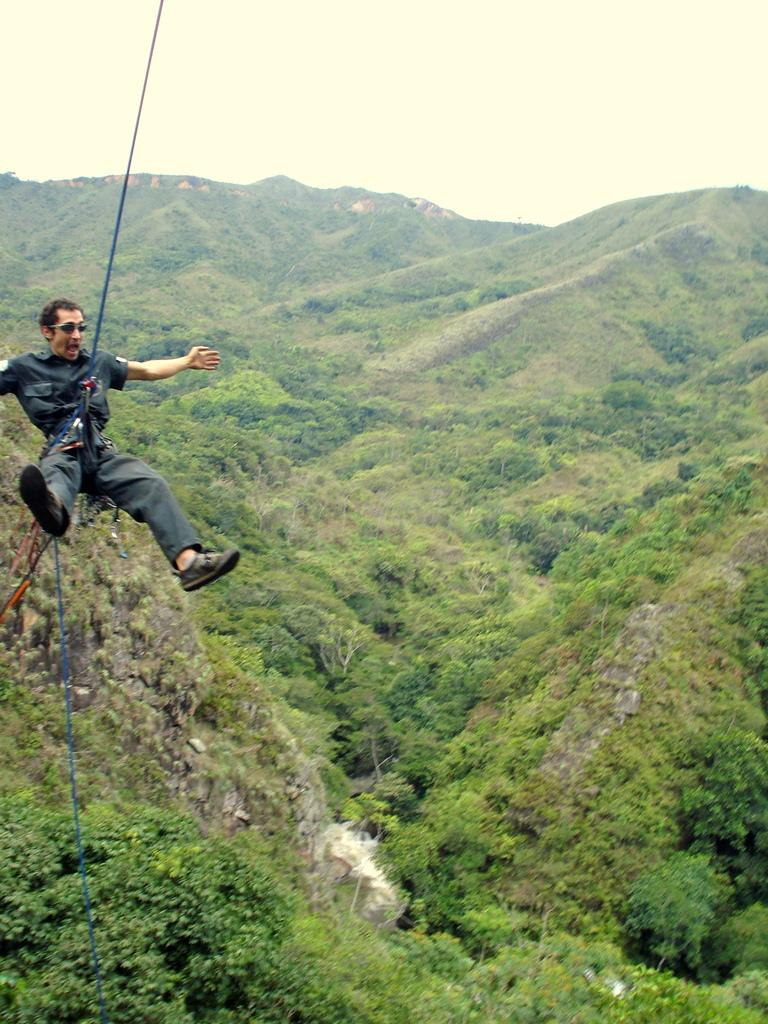What is the main subject of the image? There is a man in the image. What activity is the man engaged in? The man is either abseiling or paragliding. What can be seen at the bottom of the image? There are trees at the bottom of the image. What is visible in the background of the image? Trees and hills are visible in the background of the image. What is visible at the top of the image? The sky is visible at the top of the image. What type of tools does the carpenter use in the image? There is no carpenter present in the image, and therefore no tools can be observed. Can you describe the fangs of the creature in the image? There is no creature with fangs present in the image. 